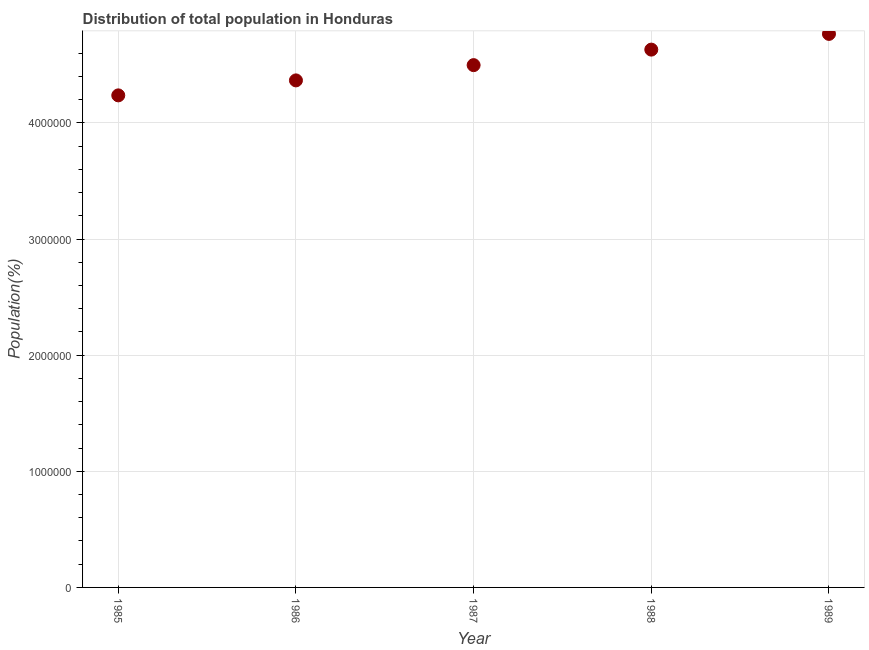What is the population in 1987?
Give a very brief answer. 4.50e+06. Across all years, what is the maximum population?
Keep it short and to the point. 4.77e+06. Across all years, what is the minimum population?
Make the answer very short. 4.24e+06. What is the sum of the population?
Offer a terse response. 2.25e+07. What is the difference between the population in 1987 and 1989?
Your answer should be compact. -2.69e+05. What is the average population per year?
Your answer should be compact. 4.50e+06. What is the median population?
Offer a terse response. 4.50e+06. What is the ratio of the population in 1988 to that in 1989?
Provide a short and direct response. 0.97. Is the population in 1986 less than that in 1989?
Your response must be concise. Yes. Is the difference between the population in 1986 and 1988 greater than the difference between any two years?
Make the answer very short. No. What is the difference between the highest and the second highest population?
Provide a succinct answer. 1.35e+05. What is the difference between the highest and the lowest population?
Provide a short and direct response. 5.29e+05. How many dotlines are there?
Make the answer very short. 1. Does the graph contain any zero values?
Give a very brief answer. No. What is the title of the graph?
Make the answer very short. Distribution of total population in Honduras . What is the label or title of the Y-axis?
Your response must be concise. Population(%). What is the Population(%) in 1985?
Make the answer very short. 4.24e+06. What is the Population(%) in 1986?
Your answer should be compact. 4.37e+06. What is the Population(%) in 1987?
Your response must be concise. 4.50e+06. What is the Population(%) in 1988?
Your answer should be very brief. 4.63e+06. What is the Population(%) in 1989?
Provide a short and direct response. 4.77e+06. What is the difference between the Population(%) in 1985 and 1986?
Your answer should be very brief. -1.29e+05. What is the difference between the Population(%) in 1985 and 1987?
Provide a short and direct response. -2.60e+05. What is the difference between the Population(%) in 1985 and 1988?
Keep it short and to the point. -3.94e+05. What is the difference between the Population(%) in 1985 and 1989?
Your response must be concise. -5.29e+05. What is the difference between the Population(%) in 1986 and 1987?
Provide a succinct answer. -1.31e+05. What is the difference between the Population(%) in 1986 and 1988?
Give a very brief answer. -2.65e+05. What is the difference between the Population(%) in 1986 and 1989?
Ensure brevity in your answer.  -4.00e+05. What is the difference between the Population(%) in 1987 and 1988?
Your answer should be very brief. -1.34e+05. What is the difference between the Population(%) in 1987 and 1989?
Ensure brevity in your answer.  -2.69e+05. What is the difference between the Population(%) in 1988 and 1989?
Your response must be concise. -1.35e+05. What is the ratio of the Population(%) in 1985 to that in 1986?
Give a very brief answer. 0.97. What is the ratio of the Population(%) in 1985 to that in 1987?
Your answer should be compact. 0.94. What is the ratio of the Population(%) in 1985 to that in 1988?
Offer a very short reply. 0.92. What is the ratio of the Population(%) in 1985 to that in 1989?
Your answer should be compact. 0.89. What is the ratio of the Population(%) in 1986 to that in 1987?
Your answer should be compact. 0.97. What is the ratio of the Population(%) in 1986 to that in 1988?
Keep it short and to the point. 0.94. What is the ratio of the Population(%) in 1986 to that in 1989?
Provide a succinct answer. 0.92. What is the ratio of the Population(%) in 1987 to that in 1989?
Make the answer very short. 0.94. What is the ratio of the Population(%) in 1988 to that in 1989?
Your answer should be compact. 0.97. 